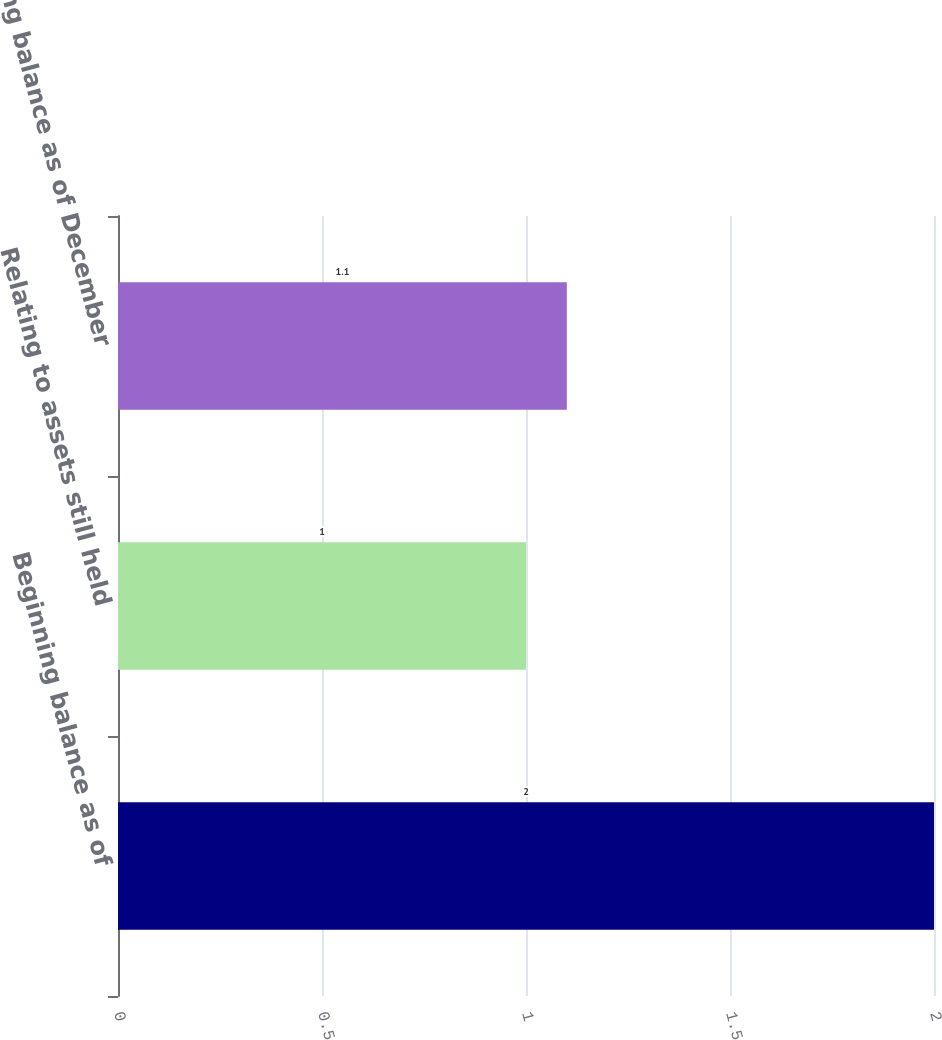Convert chart to OTSL. <chart><loc_0><loc_0><loc_500><loc_500><bar_chart><fcel>Beginning balance as of<fcel>Relating to assets still held<fcel>Ending balance as of December<nl><fcel>2<fcel>1<fcel>1.1<nl></chart> 